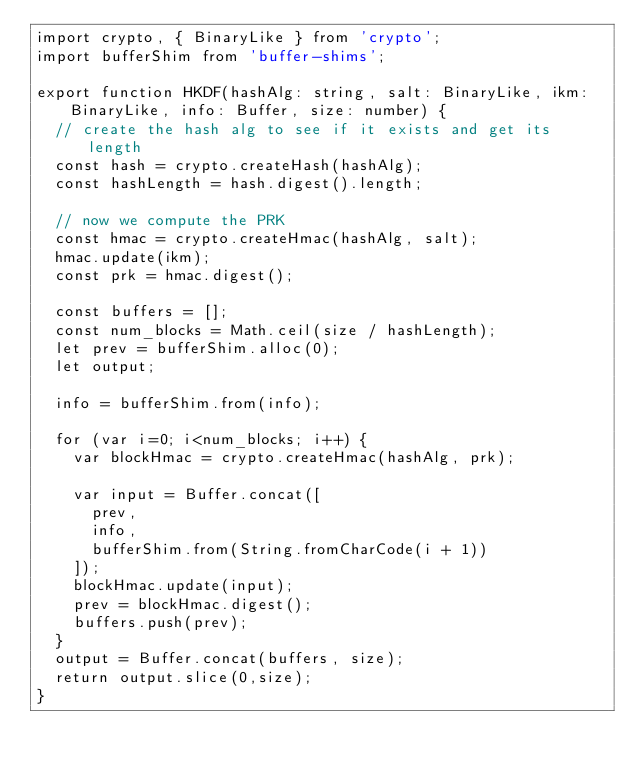Convert code to text. <code><loc_0><loc_0><loc_500><loc_500><_TypeScript_>import crypto, { BinaryLike } from 'crypto';
import bufferShim from 'buffer-shims';

export function HKDF(hashAlg: string, salt: BinaryLike, ikm: BinaryLike, info: Buffer, size: number) {
  // create the hash alg to see if it exists and get its length
  const hash = crypto.createHash(hashAlg);
  const hashLength = hash.digest().length;

  // now we compute the PRK
  const hmac = crypto.createHmac(hashAlg, salt);
  hmac.update(ikm);
  const prk = hmac.digest();

  const buffers = [];
  const num_blocks = Math.ceil(size / hashLength);
  let prev = bufferShim.alloc(0);
  let output;

  info = bufferShim.from(info);

  for (var i=0; i<num_blocks; i++) {
    var blockHmac = crypto.createHmac(hashAlg, prk);

    var input = Buffer.concat([
      prev,
      info,
      bufferShim.from(String.fromCharCode(i + 1))
    ]);
    blockHmac.update(input);
    prev = blockHmac.digest();
    buffers.push(prev);
  }
  output = Buffer.concat(buffers, size);
  return output.slice(0,size);
}
</code> 